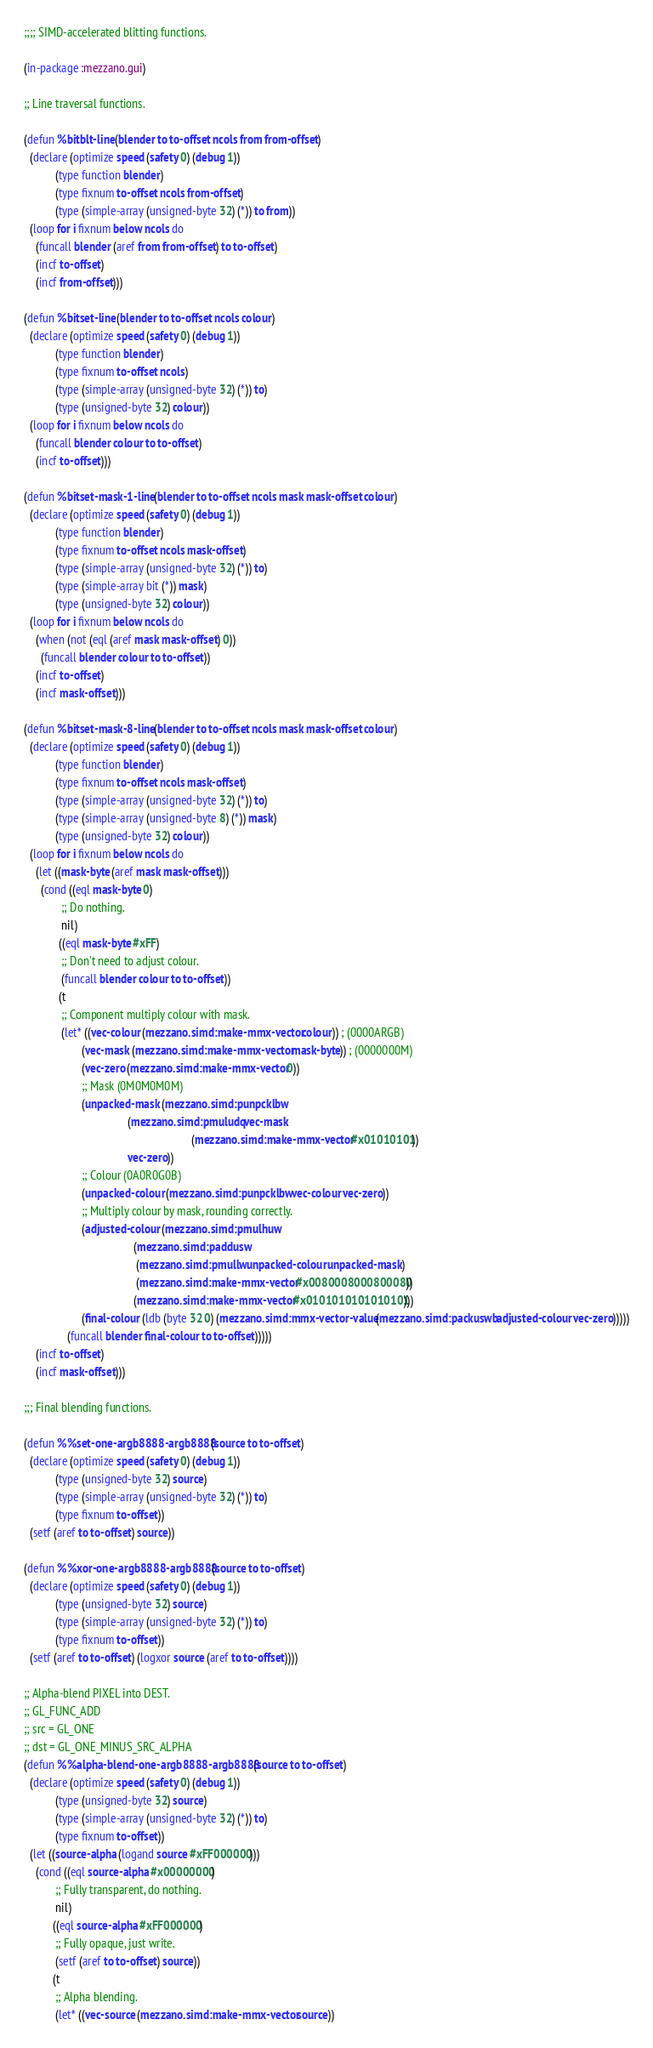<code> <loc_0><loc_0><loc_500><loc_500><_Lisp_>;;;; SIMD-accelerated blitting functions.

(in-package :mezzano.gui)

;; Line traversal functions.

(defun %bitblt-line (blender to to-offset ncols from from-offset)
  (declare (optimize speed (safety 0) (debug 1))
           (type function blender)
           (type fixnum to-offset ncols from-offset)
           (type (simple-array (unsigned-byte 32) (*)) to from))
  (loop for i fixnum below ncols do
    (funcall blender (aref from from-offset) to to-offset)
    (incf to-offset)
    (incf from-offset)))

(defun %bitset-line (blender to to-offset ncols colour)
  (declare (optimize speed (safety 0) (debug 1))
           (type function blender)
           (type fixnum to-offset ncols)
           (type (simple-array (unsigned-byte 32) (*)) to)
           (type (unsigned-byte 32) colour))
  (loop for i fixnum below ncols do
    (funcall blender colour to to-offset)
    (incf to-offset)))

(defun %bitset-mask-1-line (blender to to-offset ncols mask mask-offset colour)
  (declare (optimize speed (safety 0) (debug 1))
           (type function blender)
           (type fixnum to-offset ncols mask-offset)
           (type (simple-array (unsigned-byte 32) (*)) to)
           (type (simple-array bit (*)) mask)
           (type (unsigned-byte 32) colour))
  (loop for i fixnum below ncols do
    (when (not (eql (aref mask mask-offset) 0))
      (funcall blender colour to to-offset))
    (incf to-offset)
    (incf mask-offset)))

(defun %bitset-mask-8-line (blender to to-offset ncols mask mask-offset colour)
  (declare (optimize speed (safety 0) (debug 1))
           (type function blender)
           (type fixnum to-offset ncols mask-offset)
           (type (simple-array (unsigned-byte 32) (*)) to)
           (type (simple-array (unsigned-byte 8) (*)) mask)
           (type (unsigned-byte 32) colour))
  (loop for i fixnum below ncols do
    (let ((mask-byte (aref mask mask-offset)))
      (cond ((eql mask-byte 0)
             ;; Do nothing.
             nil)
            ((eql mask-byte #xFF)
             ;; Don't need to adjust colour.
             (funcall blender colour to to-offset))
            (t
             ;; Component multiply colour with mask.
             (let* ((vec-colour (mezzano.simd:make-mmx-vector colour)) ; (0000ARGB)
                    (vec-mask (mezzano.simd:make-mmx-vector mask-byte)) ; (0000000M)
                    (vec-zero (mezzano.simd:make-mmx-vector 0))
                    ;; Mask (0M0M0M0M)
                    (unpacked-mask (mezzano.simd:punpcklbw
                                    (mezzano.simd:pmuludq vec-mask
                                                          (mezzano.simd:make-mmx-vector #x01010101))
                                    vec-zero))
                    ;; Colour (0A0R0G0B)
                    (unpacked-colour (mezzano.simd:punpcklbw vec-colour vec-zero))
                    ;; Multiply colour by mask, rounding correctly.
                    (adjusted-colour (mezzano.simd:pmulhuw
                                      (mezzano.simd:paddusw
                                       (mezzano.simd:pmullw unpacked-colour unpacked-mask)
                                       (mezzano.simd:make-mmx-vector #x0080008000800080))
                                      (mezzano.simd:make-mmx-vector #x0101010101010101)))
                    (final-colour (ldb (byte 32 0) (mezzano.simd:mmx-vector-value (mezzano.simd:packuswb adjusted-colour vec-zero)))))
               (funcall blender final-colour to to-offset)))))
    (incf to-offset)
    (incf mask-offset)))

;;; Final blending functions.

(defun %%set-one-argb8888-argb8888 (source to to-offset)
  (declare (optimize speed (safety 0) (debug 1))
           (type (unsigned-byte 32) source)
           (type (simple-array (unsigned-byte 32) (*)) to)
           (type fixnum to-offset))
  (setf (aref to to-offset) source))

(defun %%xor-one-argb8888-argb8888 (source to to-offset)
  (declare (optimize speed (safety 0) (debug 1))
           (type (unsigned-byte 32) source)
           (type (simple-array (unsigned-byte 32) (*)) to)
           (type fixnum to-offset))
  (setf (aref to to-offset) (logxor source (aref to to-offset))))

;; Alpha-blend PIXEL into DEST.
;; GL_FUNC_ADD
;; src = GL_ONE
;; dst = GL_ONE_MINUS_SRC_ALPHA
(defun %%alpha-blend-one-argb8888-argb8888 (source to to-offset)
  (declare (optimize speed (safety 0) (debug 1))
           (type (unsigned-byte 32) source)
           (type (simple-array (unsigned-byte 32) (*)) to)
           (type fixnum to-offset))
  (let ((source-alpha (logand source #xFF000000)))
    (cond ((eql source-alpha #x00000000)
           ;; Fully transparent, do nothing.
           nil)
          ((eql source-alpha #xFF000000)
           ;; Fully opaque, just write.
           (setf (aref to to-offset) source))
          (t
           ;; Alpha blending.
           (let* ((vec-source (mezzano.simd:make-mmx-vector source))</code> 